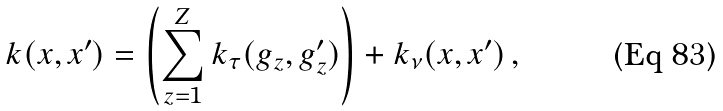<formula> <loc_0><loc_0><loc_500><loc_500>k ( x , x ^ { \prime } ) = \left ( \sum _ { z = 1 } ^ { Z } k _ { \tau } ( g _ { z } , g _ { z } ^ { \prime } ) \right ) + k _ { \nu } ( x , x ^ { \prime } ) \, ,</formula> 